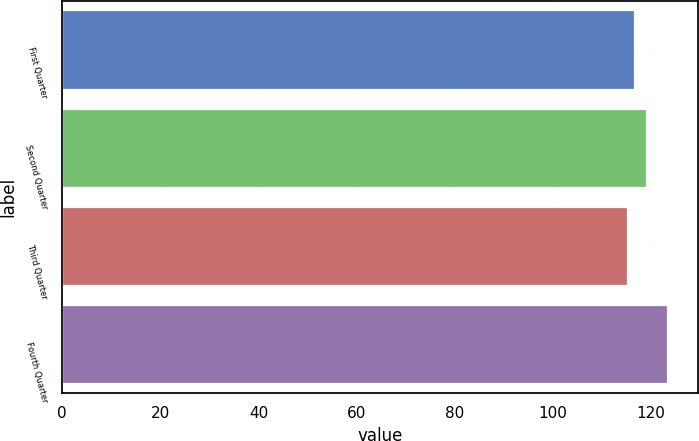<chart> <loc_0><loc_0><loc_500><loc_500><bar_chart><fcel>First Quarter<fcel>Second Quarter<fcel>Third Quarter<fcel>Fourth Quarter<nl><fcel>116.54<fcel>118.88<fcel>115.18<fcel>123.32<nl></chart> 